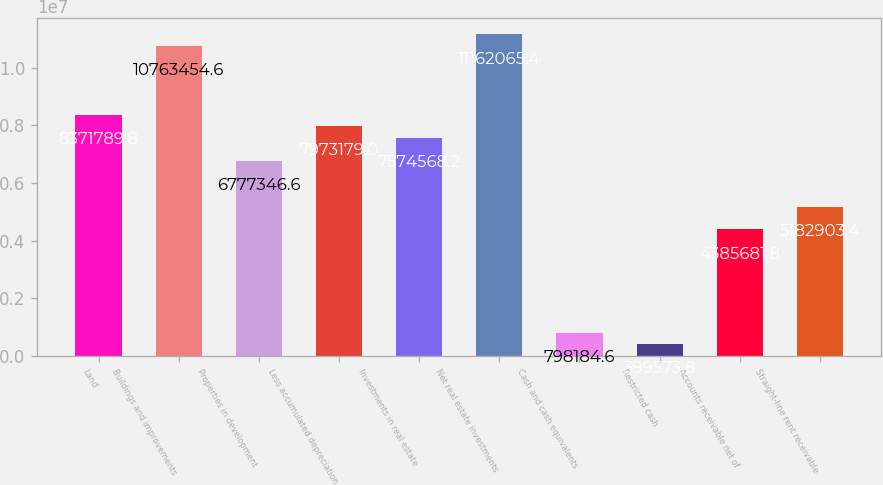Convert chart. <chart><loc_0><loc_0><loc_500><loc_500><bar_chart><fcel>Land<fcel>Buildings and improvements<fcel>Properties in development<fcel>Less accumulated depreciation<fcel>Investments in real estate<fcel>Net real estate investments<fcel>Cash and cash equivalents<fcel>Restricted cash<fcel>Accounts receivable net of<fcel>Straight-line rent receivable<nl><fcel>8.37179e+06<fcel>1.07635e+07<fcel>6.77735e+06<fcel>7.97318e+06<fcel>7.57457e+06<fcel>1.11621e+07<fcel>798185<fcel>399574<fcel>4.38568e+06<fcel>5.1829e+06<nl></chart> 